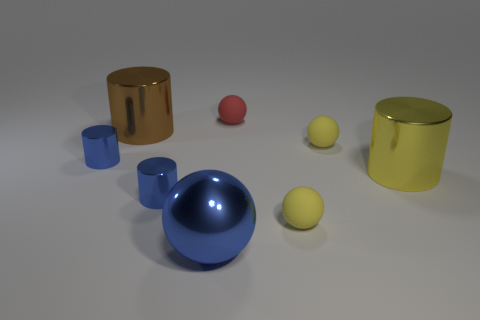Is the number of tiny metal cylinders behind the red thing less than the number of brown cylinders left of the large brown cylinder?
Your answer should be compact. No. There is a metal thing that is right of the tiny ball that is in front of the small blue cylinder that is right of the brown metal cylinder; how big is it?
Your answer should be compact. Large. There is a matte object behind the big cylinder to the left of the big blue metallic sphere; what shape is it?
Make the answer very short. Sphere. What is the shape of the small yellow matte object that is in front of the large yellow metallic thing?
Provide a short and direct response. Sphere. There is a thing that is both to the right of the small red rubber object and behind the big yellow metallic cylinder; what is its shape?
Provide a short and direct response. Sphere. How many blue objects are either spheres or large shiny things?
Ensure brevity in your answer.  1. Is the color of the small shiny thing that is in front of the large yellow metallic object the same as the large sphere?
Your answer should be very brief. Yes. There is a brown metallic thing that is left of the small matte sphere behind the brown metallic object; how big is it?
Your answer should be compact. Large. There is a blue thing that is the same size as the brown metal thing; what is its material?
Ensure brevity in your answer.  Metal. How many other objects are the same size as the yellow metal cylinder?
Your answer should be compact. 2. 